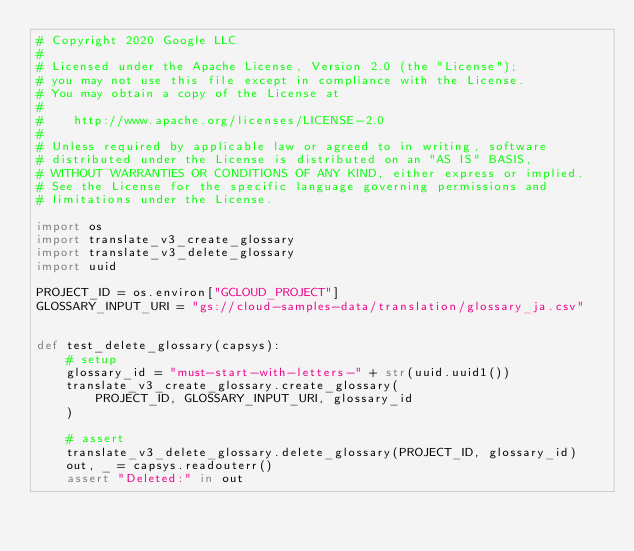<code> <loc_0><loc_0><loc_500><loc_500><_Python_># Copyright 2020 Google LLC
#
# Licensed under the Apache License, Version 2.0 (the "License");
# you may not use this file except in compliance with the License.
# You may obtain a copy of the License at
#
#    http://www.apache.org/licenses/LICENSE-2.0
#
# Unless required by applicable law or agreed to in writing, software
# distributed under the License is distributed on an "AS IS" BASIS,
# WITHOUT WARRANTIES OR CONDITIONS OF ANY KIND, either express or implied.
# See the License for the specific language governing permissions and
# limitations under the License.

import os
import translate_v3_create_glossary
import translate_v3_delete_glossary
import uuid

PROJECT_ID = os.environ["GCLOUD_PROJECT"]
GLOSSARY_INPUT_URI = "gs://cloud-samples-data/translation/glossary_ja.csv"


def test_delete_glossary(capsys):
    # setup
    glossary_id = "must-start-with-letters-" + str(uuid.uuid1())
    translate_v3_create_glossary.create_glossary(
        PROJECT_ID, GLOSSARY_INPUT_URI, glossary_id
    )

    # assert
    translate_v3_delete_glossary.delete_glossary(PROJECT_ID, glossary_id)
    out, _ = capsys.readouterr()
    assert "Deleted:" in out
</code> 